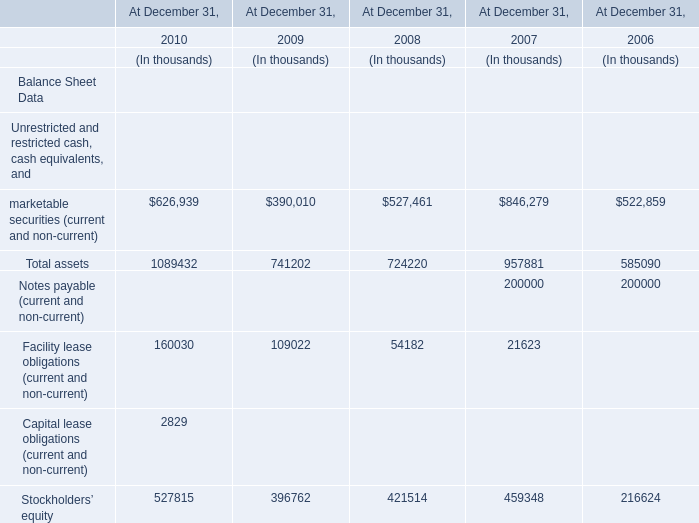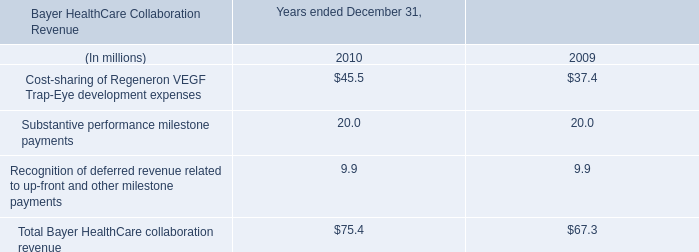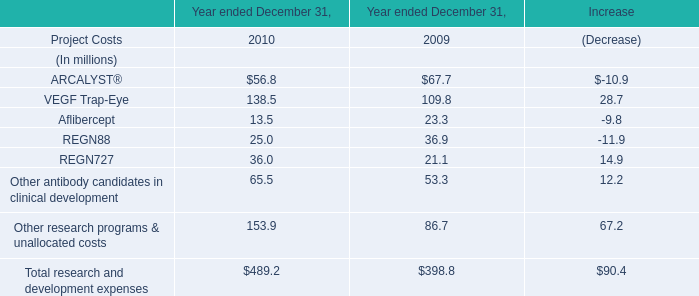What was the total value of the Total assets at December 31,2008 and the Total assets at December 31,2009? (in thousand) 
Computations: (724220 + 741202)
Answer: 1465422.0. 